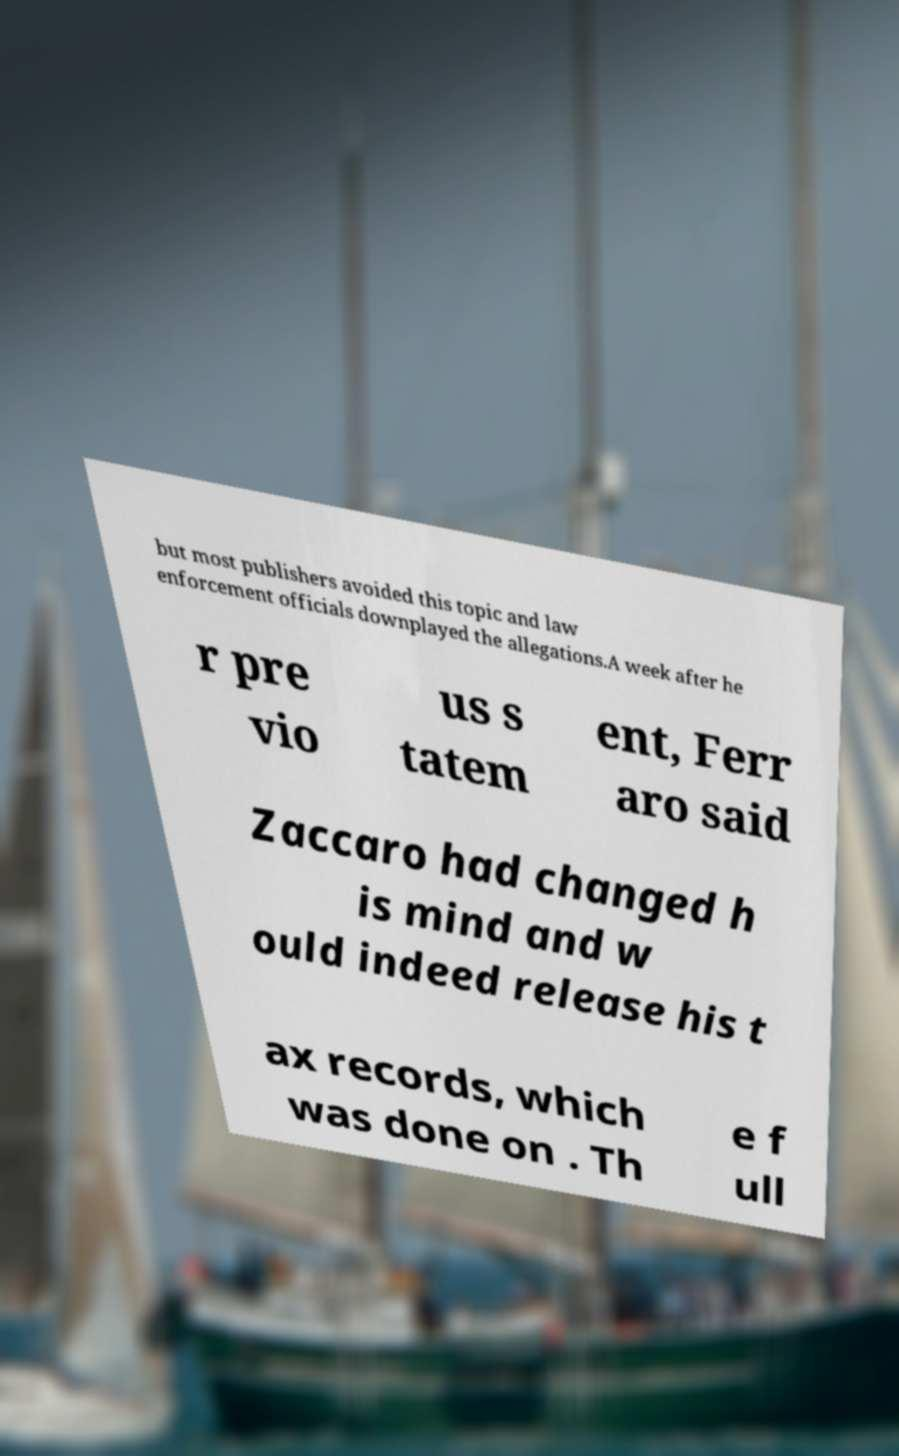There's text embedded in this image that I need extracted. Can you transcribe it verbatim? but most publishers avoided this topic and law enforcement officials downplayed the allegations.A week after he r pre vio us s tatem ent, Ferr aro said Zaccaro had changed h is mind and w ould indeed release his t ax records, which was done on . Th e f ull 